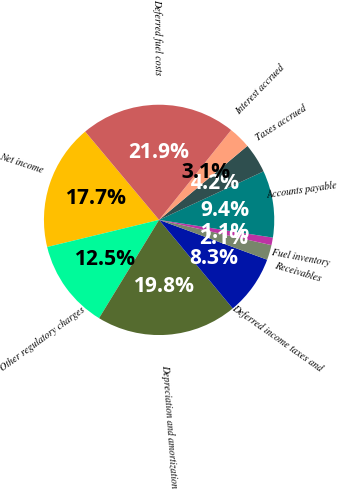Convert chart. <chart><loc_0><loc_0><loc_500><loc_500><pie_chart><fcel>Net income<fcel>Other regulatory charges<fcel>Depreciation and amortization<fcel>Deferred income taxes and<fcel>Receivables<fcel>Fuel inventory<fcel>Accounts payable<fcel>Taxes accrued<fcel>Interest accrued<fcel>Deferred fuel costs<nl><fcel>17.69%<fcel>12.49%<fcel>19.77%<fcel>8.34%<fcel>2.1%<fcel>1.06%<fcel>9.38%<fcel>4.18%<fcel>3.14%<fcel>21.85%<nl></chart> 